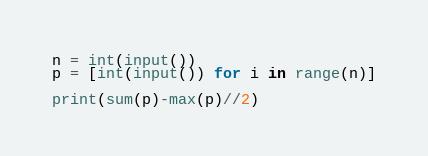Convert code to text. <code><loc_0><loc_0><loc_500><loc_500><_Python_>n = int(input())
p = [int(input()) for i in range(n)]

print(sum(p)-max(p)//2)</code> 